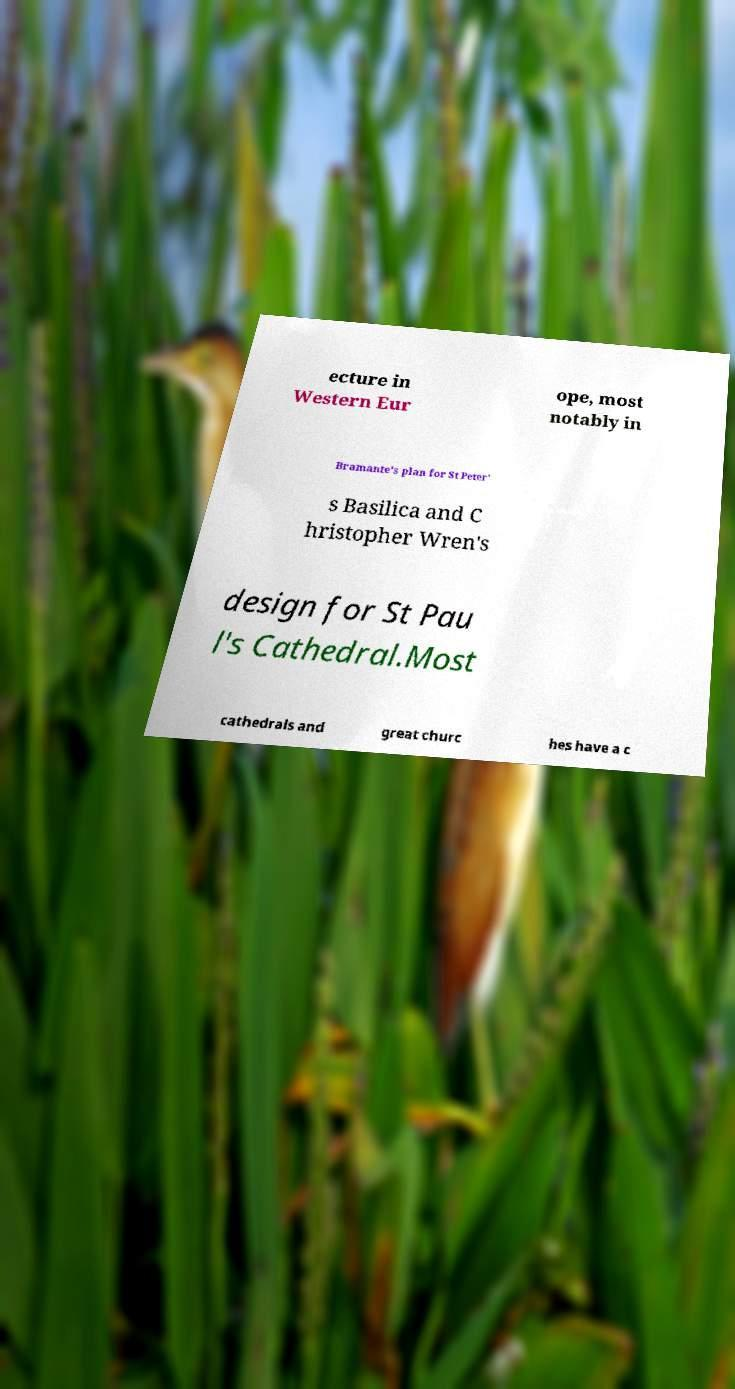Please read and relay the text visible in this image. What does it say? ecture in Western Eur ope, most notably in Bramante's plan for St Peter' s Basilica and C hristopher Wren's design for St Pau l's Cathedral.Most cathedrals and great churc hes have a c 